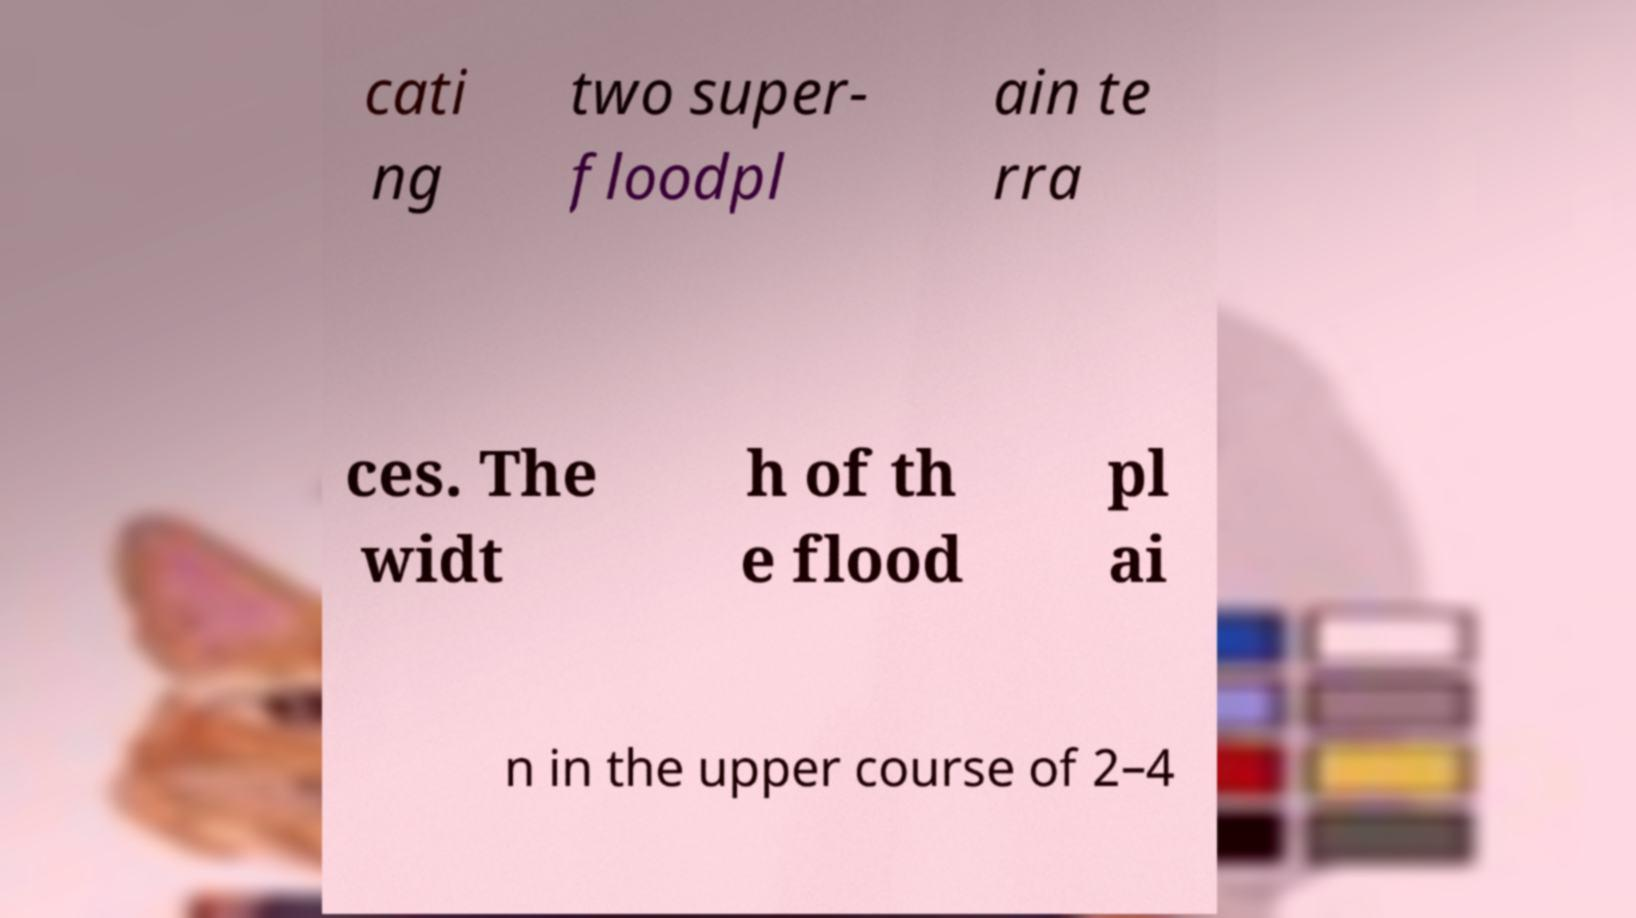I need the written content from this picture converted into text. Can you do that? cati ng two super- floodpl ain te rra ces. The widt h of th e flood pl ai n in the upper course of 2–4 